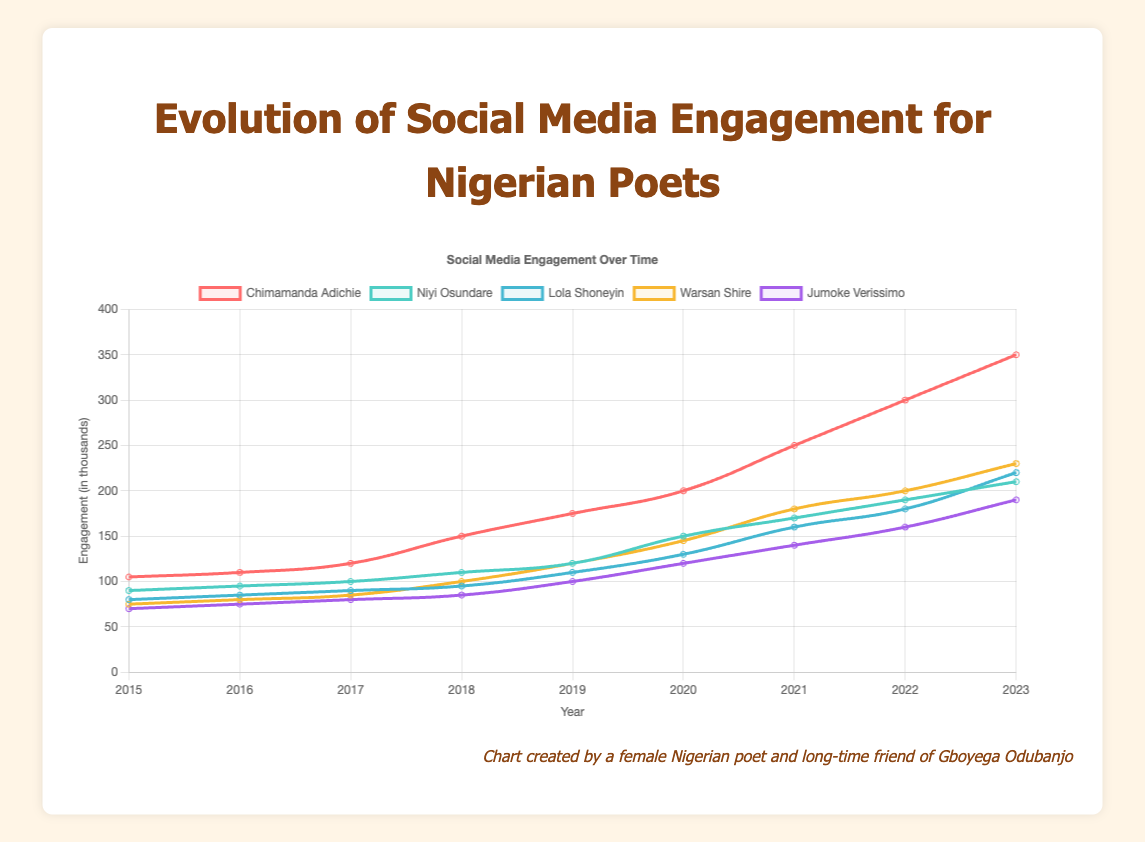Which poet showed the highest social media engagement in 2023? In the 2023 data point, Chimamanda Adichie's engagement is at 350, which is higher than all other poets.
Answer: Chimamanda Adichie Which poet had the least engagement growth between 2015 and 2023? Calculate the difference in engagement between 2015 and 2023 for each poet. Jumoke Verissimo's engagement increased by 120 (190 - 70), which is the smallest increase compared to other poets.
Answer: Jumoke Verissimo In what year did Lola Shoneyin and Niyi Osundare have equal engagement? Look for the data point where Lola Shoneyin's and Niyi Osundare's engagement values are the same. In 2018, both had an engagement of 95.
Answer: 2018 Which poet experienced the most significant increase in engagement during the pandemic period (2019-2021)? Calculate the increase in engagement from 2019 to 2021. Chimamanda Adichie saw an increase of 75 (250 - 175), which is higher than any other poet's increase during this period.
Answer: Chimamanda Adichie If you average the engagement of all poets in 2020, what value do you get? Sum the 2020 engagement values for all poets: 200 (Chimamanda Adichie) + 150 (Niyi Osundare) + 130 (Lola Shoneyin) + 145 (Warsan Shire) + 120 (Jumoke Verissimo). The total is 745. Divide by 5 to find the average: 745 / 5 = 149.
Answer: 149 Who had higher engagement in 2017, Warsan Shire or Jumoke Verissimo? Compare the 2017 engagement values for Warsan Shire (85) and Jumoke Verissimo (80). Warsan Shire had higher engagement.
Answer: Warsan Shire Which poet's engagement curve is represented by the green line? Identify the poet associated with the color green in the visualization. Niyi Osundare's engagement line is green.
Answer: Niyi Osundare From 2015 to 2023, which poet had the most consistent increase in engagement each year? Look at each poet's year-by-year engagement changes. Niyi Osundare's engagement increases steadily each year with small increments, indicating consistency.
Answer: Niyi Osundare What's the total social media engagement for all poets combined in 2019? Sum the 2019 engagement values for all poets: 175 (Chimamanda Adichie) + 120 (Niyi Osundare) + 110 (Lola Shoneyin) + 120 (Warsan Shire) + 100 (Jumoke Verissimo). The total is 625.
Answer: 625 In what year did Chimamanda Adichie surpass 250 in engagement? Identify the year when Chimamanda Adichie's engagement first exceeds 250. This happens in 2021.
Answer: 2021 